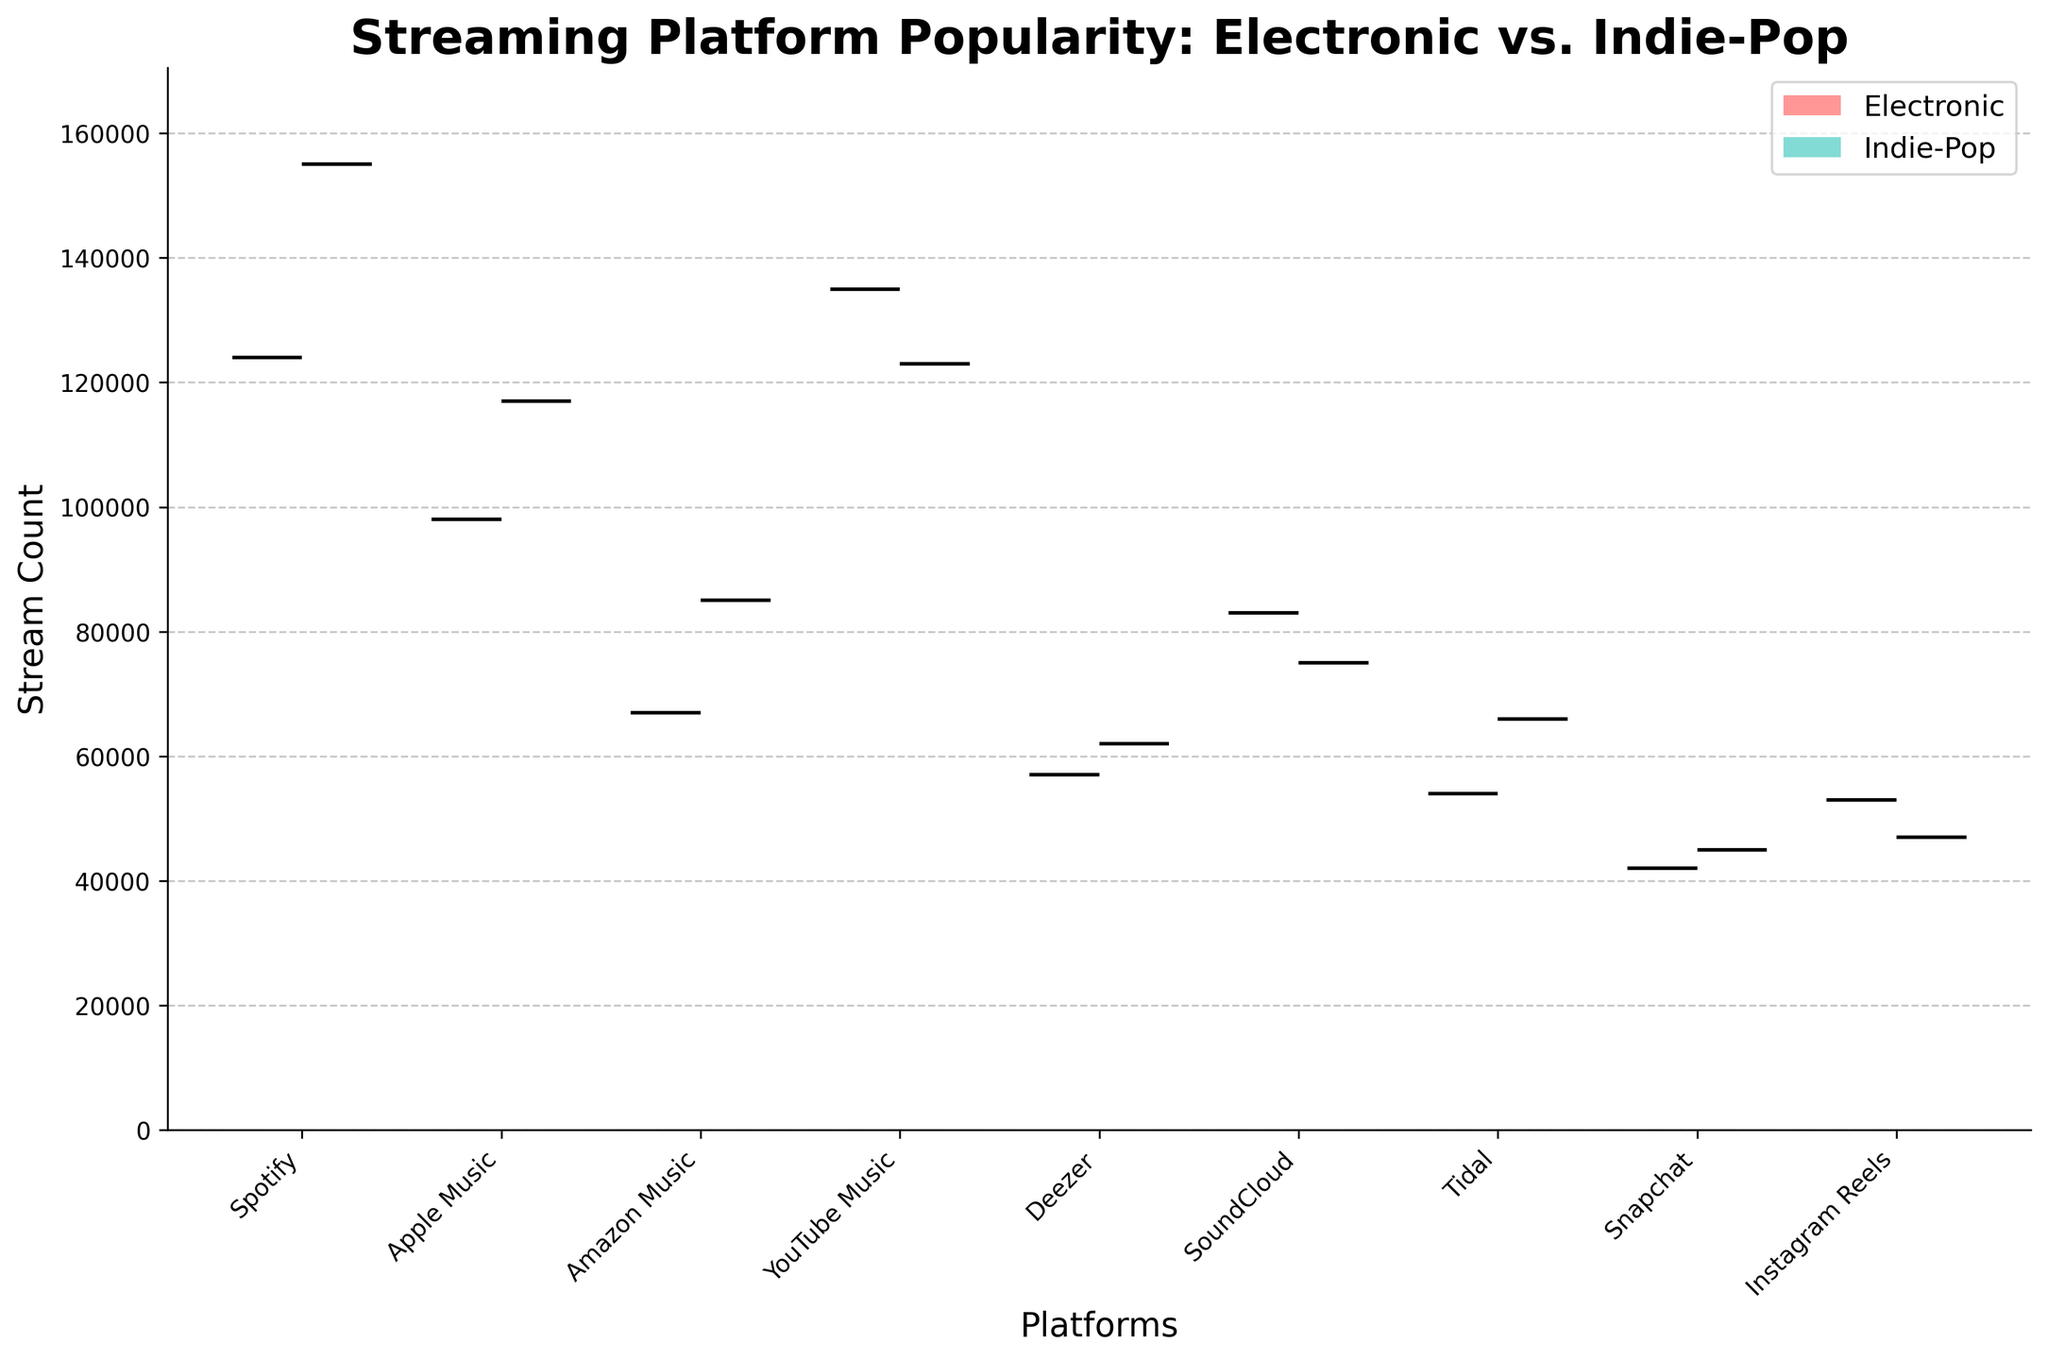What is the title of the figure? The title of the figure is located at the top and provides an overview of the chart's content. Here, the title is "Streaming Platform Popularity: Electronic vs. Indie-Pop."
Answer: Streaming Platform Popularity: Electronic vs. Indie-Pop Which platforms show data for both Electronic and Indie-Pop genres? By inspecting the x-axis labels, each platform's data is represented twice, once for each genre. Platforms with both genre data are Spotify, Apple Music, Amazon Music, YouTube Music, Deezer, SoundCloud, Tidal, Snapchat, and Instagram Reels.
Answer: Spotify, Apple Music, Amazon Music, YouTube Music, Deezer, SoundCloud, Tidal, Snapchat, Instagram Reels For which genre does Spotify have a higher stream count, and by how much? Look at the median positions of the box plots for Spotify. The median stream count for Electronic is around 124,000, while for Indie-Pop, it's about 155,000. The difference between these counts is 31,000.
Answer: Indie-Pop, by 31,000 What is the range of the stream count for YouTube Music for Indie-Pop? Examine the YouTube Music box plot for Indie-Pop. The top whisker indicates the maximum, around 123,000 streams. The bottom whisker indicates the minimum, around 123,000 streams. The range is calculated by subtracting the minimum from the maximum.
Answer: 0 (because min and max are the same) Which genre has a higher median stream count on Apple Music? Compare the medians of the box plots for Apple Music for both genres. The Indie-Pop genre has a higher median stream count than Electronic.
Answer: Indie-Pop Which platform has the lowest median stream count for both genres? Scan the box plots to find the platform with the lowest median stream count for both genres. Tidal has the lowest median for both Electronic and Indie-Pop.
Answer: Tidal For Electronic, which platform shows the highest range of stream counts? Check the distance between the top and bottom whiskers for each platform in the Electronic genre. YouTube Music shows the highest range in stream counts for Electronic.
Answer: YouTube Music What is the difference in the median stream count between Deezer for Electronic and Indie-Pop? Identify the median positions for Deezer for both genres. The median for Electronic is approximately 57,000, and for Indie-Pop, it is around 62,000. The difference is 5,000.
Answer: 5,000 For the platforms exclusively highlighted for new media (Snapchat and Instagram Reels), which genre shows higher overall popularity? Compare the box plots for Snapchat and Instagram Reels within each genre. Both platforms show a slightly higher median stream count for Indie-Pop.
Answer: Indie-Pop Is there a pattern in the median stream counts for SoundCloud across both genres? Analyze the median positions for SoundCloud for both Electronic and Indie-Pop. The median stream count for Electronic is approximately 83,000, and for Indie-Pop, it is around 75,000, indicating Electronic generally has a higher median on SoundCloud.
Answer: Electronic has a higher median 